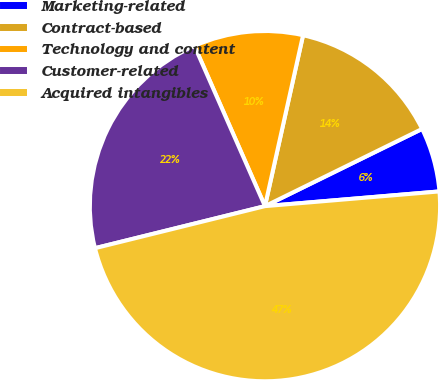Convert chart to OTSL. <chart><loc_0><loc_0><loc_500><loc_500><pie_chart><fcel>Marketing-related<fcel>Contract-based<fcel>Technology and content<fcel>Customer-related<fcel>Acquired intangibles<nl><fcel>5.93%<fcel>14.24%<fcel>10.09%<fcel>22.26%<fcel>47.48%<nl></chart> 